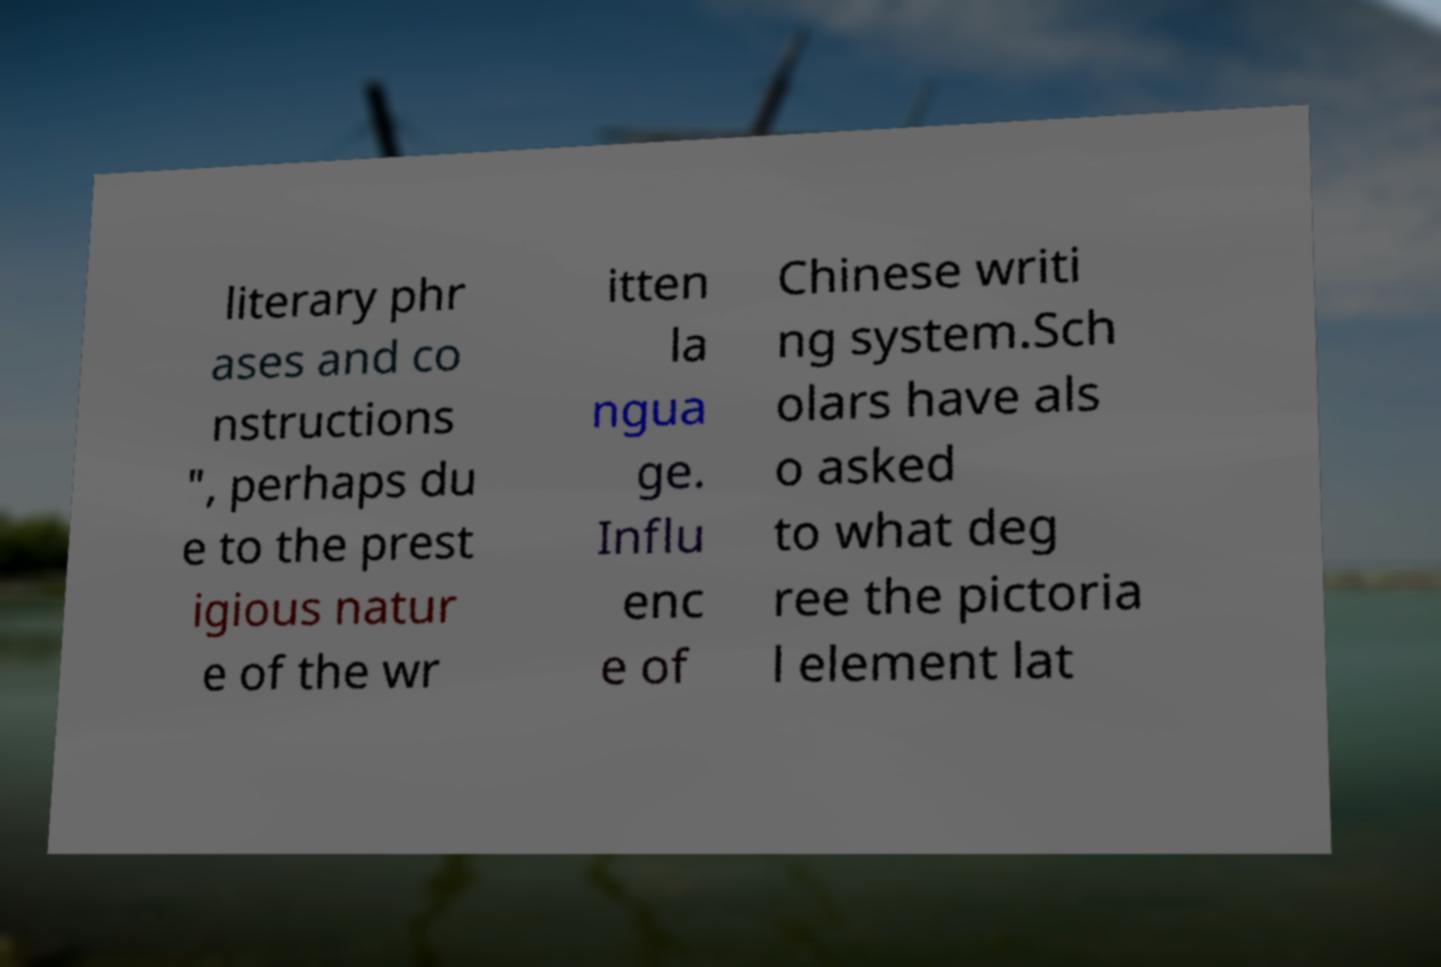Please read and relay the text visible in this image. What does it say? literary phr ases and co nstructions ", perhaps du e to the prest igious natur e of the wr itten la ngua ge. Influ enc e of Chinese writi ng system.Sch olars have als o asked to what deg ree the pictoria l element lat 